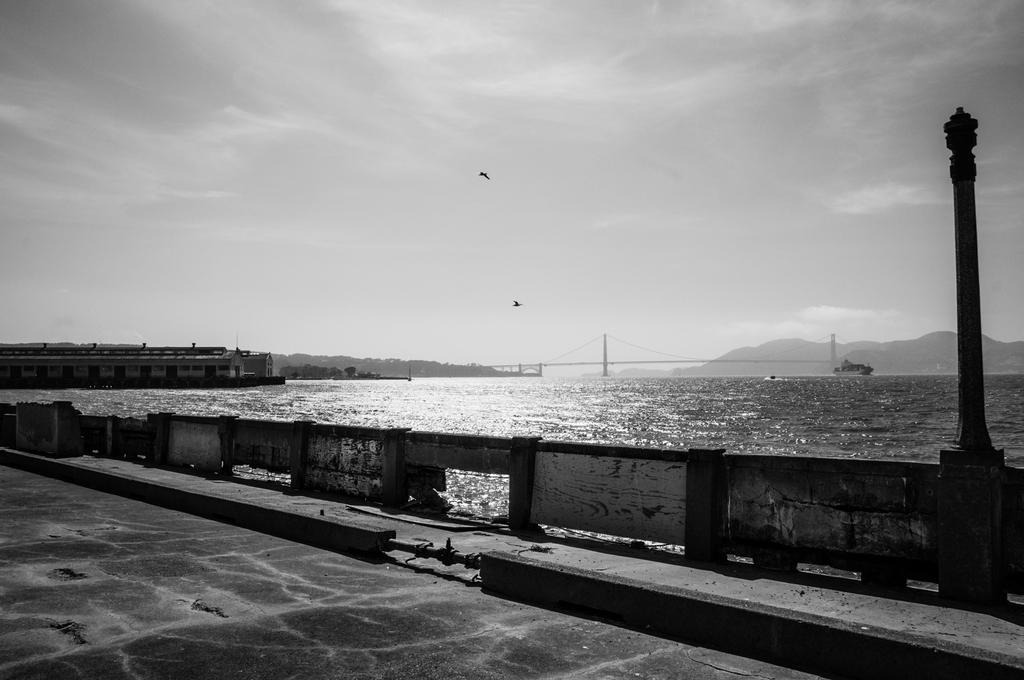What can be seen in the image that people might walk on? There is a path in the image that people might walk on. What type of structure is visible in the image? There is a walpole in the image. What is happening on the water in the image? There are boats on water in the image. What type of natural feature is visible in the image? There are mountains in the image. What type of animals can be seen in the image? There are birds in the image. What is visible in the background of the image? The sky is visible in the background of the image. What can be seen in the sky? There are clouds in the sky. How many divisions of the expert team can be seen in the image? There is no expert team or divisions present in the image. What type of slip is visible on the path in the image? There is no slip visible on the path in the image. 